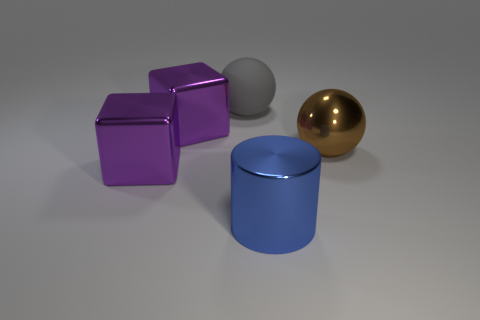Can you describe the lighting and shadows in the scene? The lighting in the image is soft and diffused, creating gentle shadows that do not have sharp edges. It comes from the upper right side, as indicated by the direction of shadows cast to the left of the objects. This lighting scenario suggests an indoor setting, possibly under the soft glow of studio lights. 